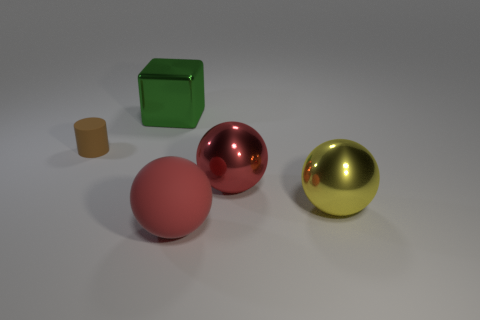Is there anything else that is the same shape as the small matte object?
Give a very brief answer. No. Does the red ball that is behind the rubber ball have the same material as the tiny brown thing?
Your response must be concise. No. The metal object that is left of the large yellow object and on the right side of the big green metal block has what shape?
Ensure brevity in your answer.  Sphere. There is a rubber thing that is on the right side of the small cylinder; are there any large red metallic balls that are in front of it?
Offer a terse response. No. What number of other objects are the same material as the cylinder?
Your response must be concise. 1. Does the large object that is behind the tiny brown cylinder have the same shape as the matte thing on the left side of the green metal thing?
Ensure brevity in your answer.  No. Are the tiny brown cylinder and the green thing made of the same material?
Your response must be concise. No. What size is the matte object that is in front of the thing on the left side of the big object that is behind the tiny cylinder?
Your answer should be compact. Large. What number of other things are there of the same color as the matte cylinder?
Keep it short and to the point. 0. There is a yellow object that is the same size as the matte sphere; what is its shape?
Offer a terse response. Sphere. 